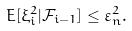Convert formula to latex. <formula><loc_0><loc_0><loc_500><loc_500>E [ \xi _ { i } ^ { 2 } | \mathcal { F } _ { i - 1 } ] \leq \varepsilon _ { n } ^ { 2 } .</formula> 